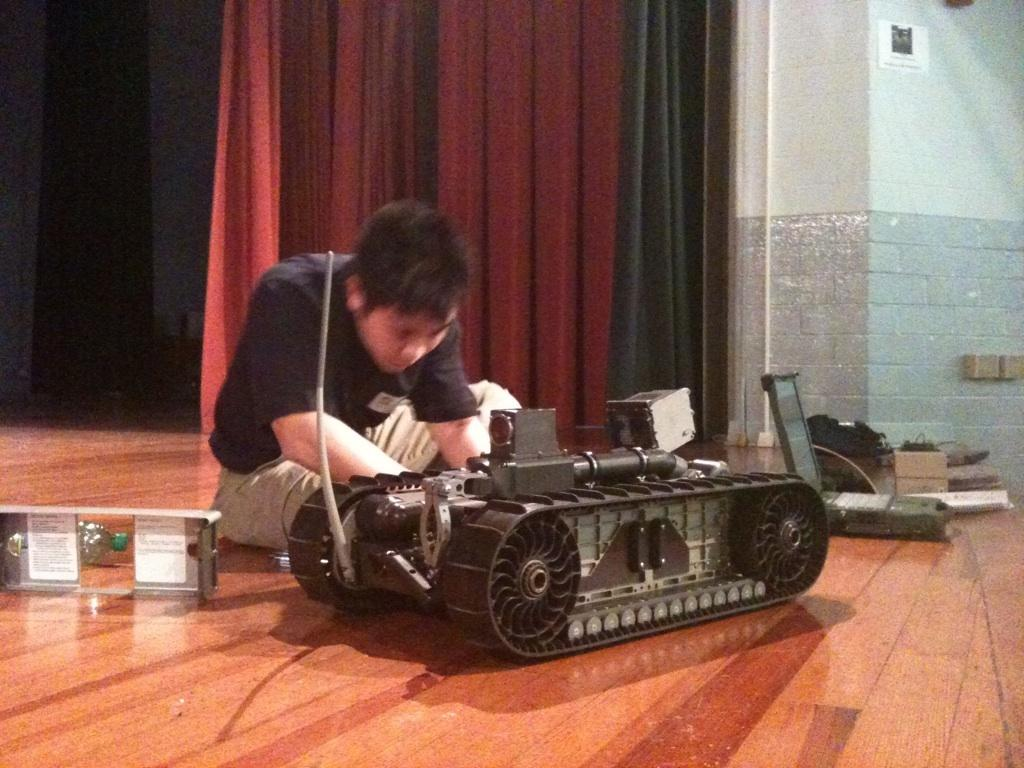What is the person in the image doing? There is a person sitting on the floor in the image. What else can be seen in the image besides the person? There is a toy and a laptop visible in the image. What type of background is visible in the image? There are walls visible in the image, and there is also a curtain. What type of bread is the person holding in the image? There is no bread or loaf present in the image. Can you see any playing cards in the image? There are no playing cards visible in the image. 